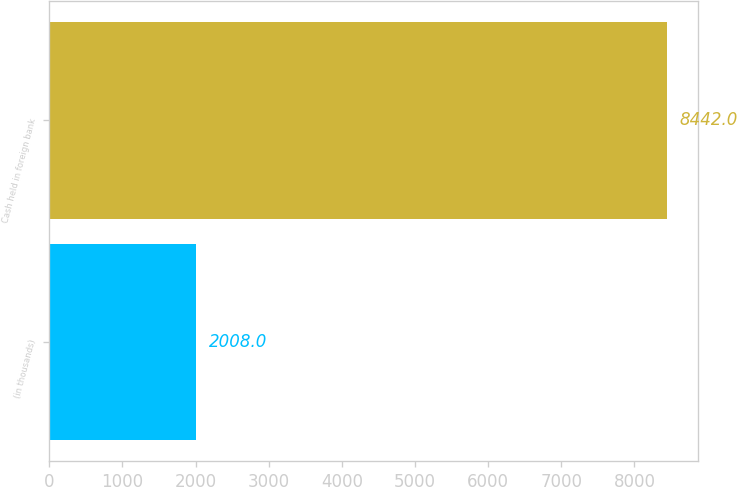Convert chart to OTSL. <chart><loc_0><loc_0><loc_500><loc_500><bar_chart><fcel>(in thousands)<fcel>Cash held in foreign bank<nl><fcel>2008<fcel>8442<nl></chart> 